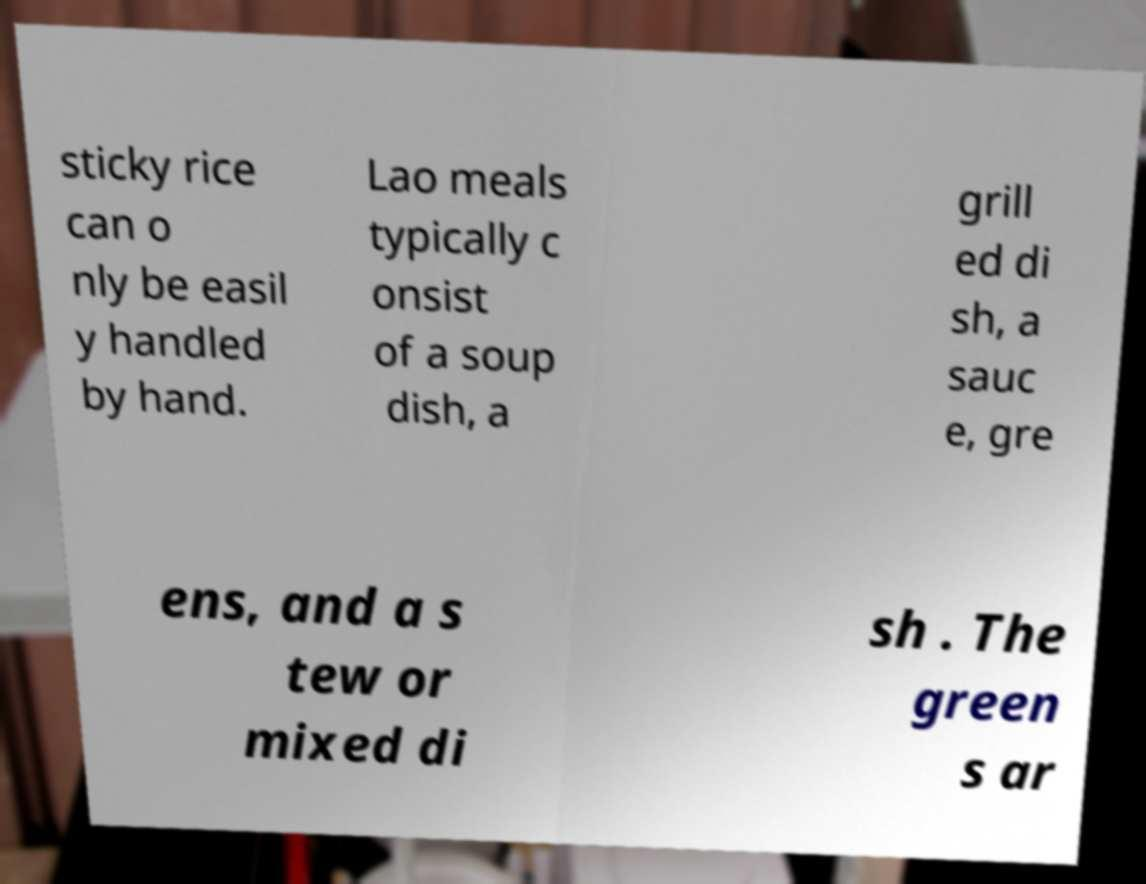Could you assist in decoding the text presented in this image and type it out clearly? sticky rice can o nly be easil y handled by hand. Lao meals typically c onsist of a soup dish, a grill ed di sh, a sauc e, gre ens, and a s tew or mixed di sh . The green s ar 